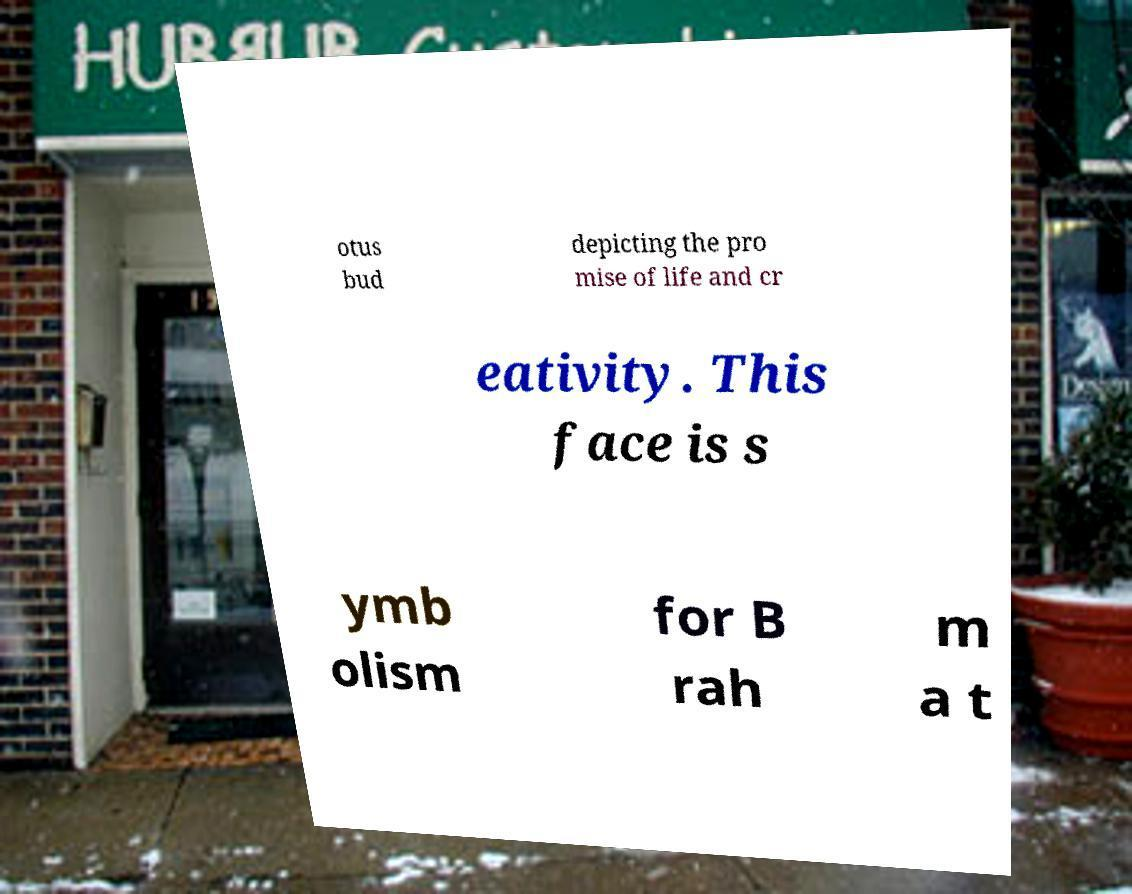For documentation purposes, I need the text within this image transcribed. Could you provide that? otus bud depicting the pro mise of life and cr eativity. This face is s ymb olism for B rah m a t 